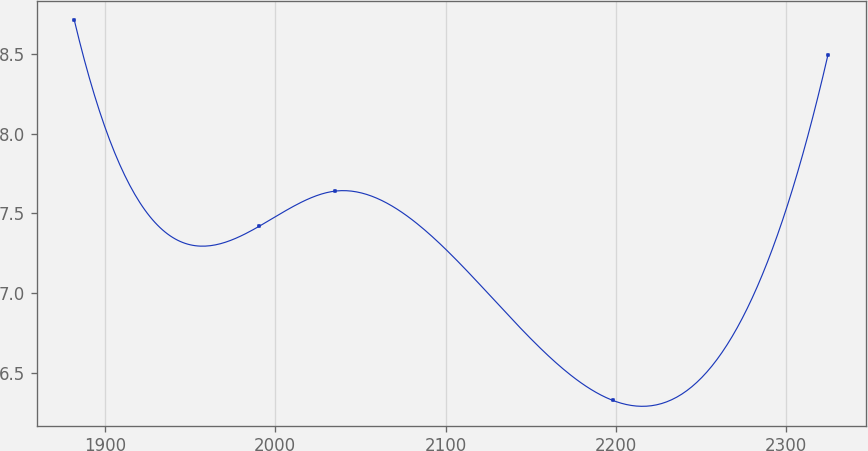<chart> <loc_0><loc_0><loc_500><loc_500><line_chart><ecel><fcel>Unnamed: 1<nl><fcel>1882.07<fcel>8.71<nl><fcel>1990.6<fcel>7.42<nl><fcel>2035.12<fcel>7.64<nl><fcel>2198.29<fcel>6.33<nl><fcel>2324.38<fcel>8.49<nl></chart> 